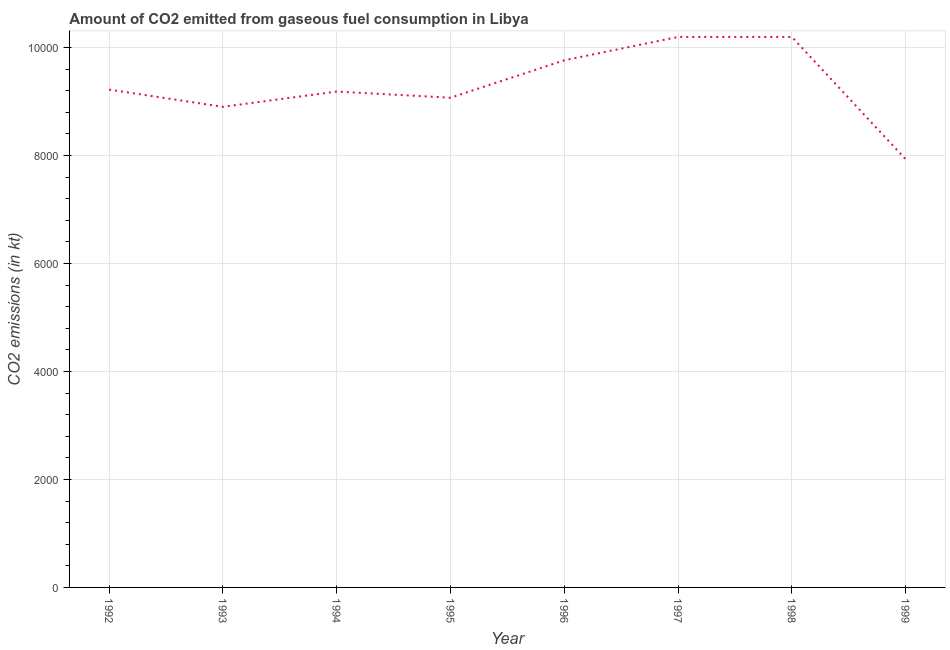What is the co2 emissions from gaseous fuel consumption in 1993?
Provide a short and direct response. 8903.48. Across all years, what is the maximum co2 emissions from gaseous fuel consumption?
Your answer should be very brief. 1.02e+04. Across all years, what is the minimum co2 emissions from gaseous fuel consumption?
Offer a very short reply. 7931.72. In which year was the co2 emissions from gaseous fuel consumption maximum?
Make the answer very short. 1997. What is the sum of the co2 emissions from gaseous fuel consumption?
Your answer should be compact. 7.45e+04. What is the difference between the co2 emissions from gaseous fuel consumption in 1996 and 1997?
Make the answer very short. -432.71. What is the average co2 emissions from gaseous fuel consumption per year?
Give a very brief answer. 9309.6. What is the median co2 emissions from gaseous fuel consumption?
Give a very brief answer. 9204.17. Do a majority of the years between 1999 and 1997 (inclusive) have co2 emissions from gaseous fuel consumption greater than 2000 kt?
Your answer should be very brief. No. What is the ratio of the co2 emissions from gaseous fuel consumption in 1996 to that in 1997?
Your response must be concise. 0.96. Is the difference between the co2 emissions from gaseous fuel consumption in 1992 and 1998 greater than the difference between any two years?
Offer a terse response. No. What is the difference between the highest and the lowest co2 emissions from gaseous fuel consumption?
Provide a succinct answer. 2266.21. In how many years, is the co2 emissions from gaseous fuel consumption greater than the average co2 emissions from gaseous fuel consumption taken over all years?
Give a very brief answer. 3. Does the co2 emissions from gaseous fuel consumption monotonically increase over the years?
Provide a short and direct response. No. How many years are there in the graph?
Offer a terse response. 8. Are the values on the major ticks of Y-axis written in scientific E-notation?
Offer a terse response. No. Does the graph contain grids?
Provide a short and direct response. Yes. What is the title of the graph?
Your answer should be compact. Amount of CO2 emitted from gaseous fuel consumption in Libya. What is the label or title of the Y-axis?
Your answer should be very brief. CO2 emissions (in kt). What is the CO2 emissions (in kt) in 1992?
Offer a very short reply. 9222.5. What is the CO2 emissions (in kt) in 1993?
Provide a succinct answer. 8903.48. What is the CO2 emissions (in kt) in 1994?
Offer a terse response. 9185.83. What is the CO2 emissions (in kt) in 1995?
Offer a very short reply. 9072.16. What is the CO2 emissions (in kt) in 1996?
Your answer should be very brief. 9765.22. What is the CO2 emissions (in kt) of 1997?
Offer a very short reply. 1.02e+04. What is the CO2 emissions (in kt) in 1998?
Provide a short and direct response. 1.02e+04. What is the CO2 emissions (in kt) of 1999?
Ensure brevity in your answer.  7931.72. What is the difference between the CO2 emissions (in kt) in 1992 and 1993?
Give a very brief answer. 319.03. What is the difference between the CO2 emissions (in kt) in 1992 and 1994?
Your answer should be compact. 36.67. What is the difference between the CO2 emissions (in kt) in 1992 and 1995?
Offer a terse response. 150.35. What is the difference between the CO2 emissions (in kt) in 1992 and 1996?
Ensure brevity in your answer.  -542.72. What is the difference between the CO2 emissions (in kt) in 1992 and 1997?
Provide a succinct answer. -975.42. What is the difference between the CO2 emissions (in kt) in 1992 and 1998?
Offer a terse response. -975.42. What is the difference between the CO2 emissions (in kt) in 1992 and 1999?
Make the answer very short. 1290.78. What is the difference between the CO2 emissions (in kt) in 1993 and 1994?
Your response must be concise. -282.36. What is the difference between the CO2 emissions (in kt) in 1993 and 1995?
Provide a succinct answer. -168.68. What is the difference between the CO2 emissions (in kt) in 1993 and 1996?
Your answer should be compact. -861.75. What is the difference between the CO2 emissions (in kt) in 1993 and 1997?
Offer a very short reply. -1294.45. What is the difference between the CO2 emissions (in kt) in 1993 and 1998?
Your answer should be very brief. -1294.45. What is the difference between the CO2 emissions (in kt) in 1993 and 1999?
Your answer should be compact. 971.75. What is the difference between the CO2 emissions (in kt) in 1994 and 1995?
Ensure brevity in your answer.  113.68. What is the difference between the CO2 emissions (in kt) in 1994 and 1996?
Give a very brief answer. -579.39. What is the difference between the CO2 emissions (in kt) in 1994 and 1997?
Your answer should be compact. -1012.09. What is the difference between the CO2 emissions (in kt) in 1994 and 1998?
Ensure brevity in your answer.  -1012.09. What is the difference between the CO2 emissions (in kt) in 1994 and 1999?
Provide a short and direct response. 1254.11. What is the difference between the CO2 emissions (in kt) in 1995 and 1996?
Make the answer very short. -693.06. What is the difference between the CO2 emissions (in kt) in 1995 and 1997?
Provide a succinct answer. -1125.77. What is the difference between the CO2 emissions (in kt) in 1995 and 1998?
Your answer should be compact. -1125.77. What is the difference between the CO2 emissions (in kt) in 1995 and 1999?
Provide a short and direct response. 1140.44. What is the difference between the CO2 emissions (in kt) in 1996 and 1997?
Your response must be concise. -432.71. What is the difference between the CO2 emissions (in kt) in 1996 and 1998?
Your response must be concise. -432.71. What is the difference between the CO2 emissions (in kt) in 1996 and 1999?
Offer a terse response. 1833.5. What is the difference between the CO2 emissions (in kt) in 1997 and 1999?
Offer a very short reply. 2266.21. What is the difference between the CO2 emissions (in kt) in 1998 and 1999?
Make the answer very short. 2266.21. What is the ratio of the CO2 emissions (in kt) in 1992 to that in 1993?
Your response must be concise. 1.04. What is the ratio of the CO2 emissions (in kt) in 1992 to that in 1996?
Offer a very short reply. 0.94. What is the ratio of the CO2 emissions (in kt) in 1992 to that in 1997?
Provide a short and direct response. 0.9. What is the ratio of the CO2 emissions (in kt) in 1992 to that in 1998?
Your response must be concise. 0.9. What is the ratio of the CO2 emissions (in kt) in 1992 to that in 1999?
Give a very brief answer. 1.16. What is the ratio of the CO2 emissions (in kt) in 1993 to that in 1994?
Provide a short and direct response. 0.97. What is the ratio of the CO2 emissions (in kt) in 1993 to that in 1996?
Your response must be concise. 0.91. What is the ratio of the CO2 emissions (in kt) in 1993 to that in 1997?
Ensure brevity in your answer.  0.87. What is the ratio of the CO2 emissions (in kt) in 1993 to that in 1998?
Make the answer very short. 0.87. What is the ratio of the CO2 emissions (in kt) in 1993 to that in 1999?
Give a very brief answer. 1.12. What is the ratio of the CO2 emissions (in kt) in 1994 to that in 1995?
Your response must be concise. 1.01. What is the ratio of the CO2 emissions (in kt) in 1994 to that in 1996?
Give a very brief answer. 0.94. What is the ratio of the CO2 emissions (in kt) in 1994 to that in 1997?
Your response must be concise. 0.9. What is the ratio of the CO2 emissions (in kt) in 1994 to that in 1998?
Your answer should be very brief. 0.9. What is the ratio of the CO2 emissions (in kt) in 1994 to that in 1999?
Ensure brevity in your answer.  1.16. What is the ratio of the CO2 emissions (in kt) in 1995 to that in 1996?
Keep it short and to the point. 0.93. What is the ratio of the CO2 emissions (in kt) in 1995 to that in 1997?
Give a very brief answer. 0.89. What is the ratio of the CO2 emissions (in kt) in 1995 to that in 1998?
Make the answer very short. 0.89. What is the ratio of the CO2 emissions (in kt) in 1995 to that in 1999?
Give a very brief answer. 1.14. What is the ratio of the CO2 emissions (in kt) in 1996 to that in 1997?
Provide a short and direct response. 0.96. What is the ratio of the CO2 emissions (in kt) in 1996 to that in 1998?
Your response must be concise. 0.96. What is the ratio of the CO2 emissions (in kt) in 1996 to that in 1999?
Provide a short and direct response. 1.23. What is the ratio of the CO2 emissions (in kt) in 1997 to that in 1999?
Provide a short and direct response. 1.29. What is the ratio of the CO2 emissions (in kt) in 1998 to that in 1999?
Offer a very short reply. 1.29. 